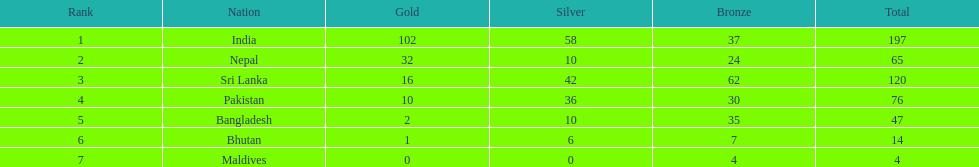Which country, apart from india, appears in the table? Nepal. 